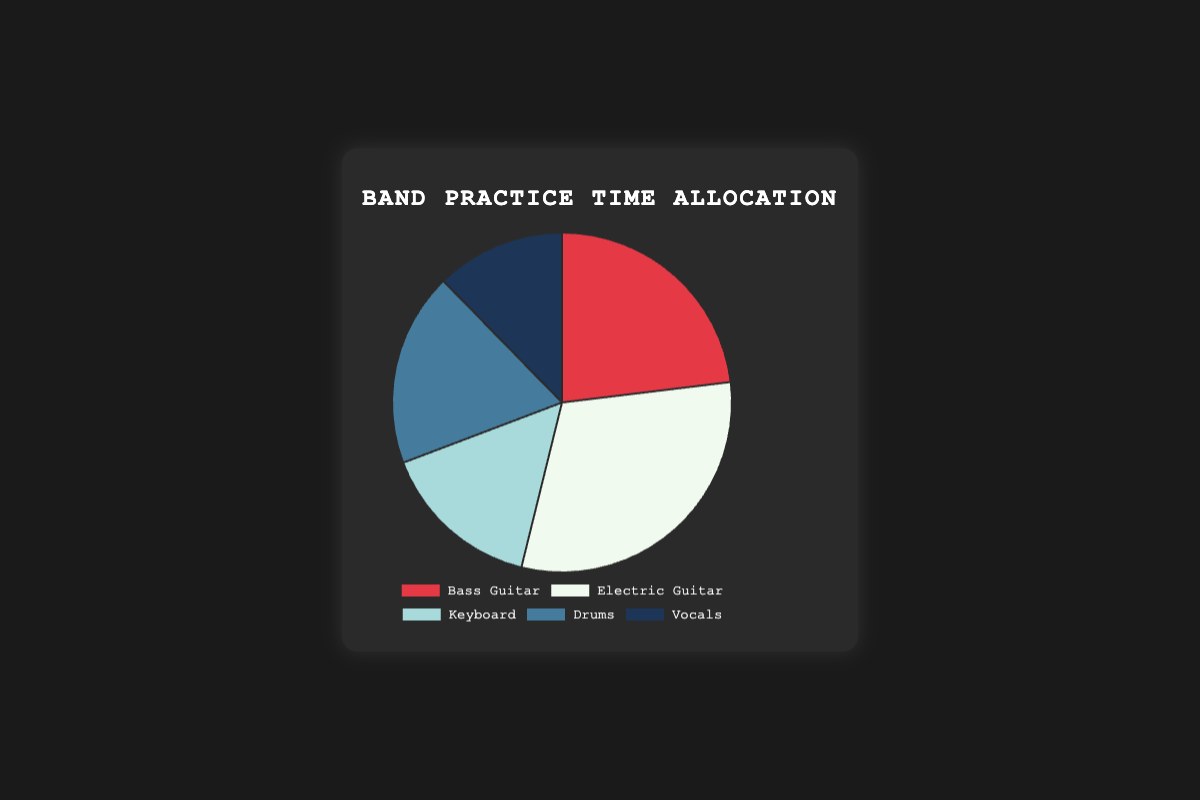Which instrument has the highest practice time allocation per week? The instrument with the highest practice time allocation can be identified by looking at the segment with the largest proportion in the pie chart. The Electric Guitar has the largest segment.
Answer: Electric Guitar Which instrument has the lowest practice time allocation per week? The instrument with the lowest practice time allocation can be identified by looking at the segment with the smallest proportion in the pie chart. The Vocals segment is the smallest.
Answer: Vocals How much more practice time is allocated to the Electric Guitar compared to the Keyboard? To find the difference, subtract the practice time of the Keyboard from the practice time of the Electric Guitar: 20 hours (Electric Guitar) - 10 hours (Keyboard).
Answer: 10 hours What is the total practice time allocated to Bass Guitar and Drums combined per week? To find the total practice time for both instruments, add their practice times: 15 hours (Bass Guitar) + 12 hours (Drums).
Answer: 27 hours What percentage of the total practice time does the Keyboard occupy? Calculate the total practice time for all instruments and then find the percentage for the Keyboard. The total is 15 + 20 + 10 + 12 + 8 = 65 hours. The percentage for the Keyboard is (10/65) * 100.
Answer: 15.38% Which instruments together make up more practice time than Drums alone? First note the practice time of Drums, which is 12 hours. Identify the pairs of other instruments whose combined practice time exceeds 12 hours. Bass Guitar (15), Electric Guitar (20), and combinations such as Bass Guitar + Keyboard (15 + 10) also exceed 12 hours.
Answer: Bass Guitar, Electric Guitar, or Bass Guitar + Keyboard What is the ratio of practice time allocated to Bass Guitar to Drums? The ratio can be found by dividing the practice time of Bass Guitar by the practice time of Drums: 15 hours (Bass Guitar) / 12 hours (Drums).
Answer: 1.25 How much total practice time is allocated to instruments excluding Electric Guitar and Vocals? Sum the practice times excluding Electric Guitar and Vocals: 15 hours (Bass Guitar) + 10 hours (Keyboard) + 12 hours (Drums).
Answer: 37 hours If practice time allocation for Vocals is increased by 50%, what will be the new practice time for Vocals? Calculate 50% of the current practice time for Vocals and add it to the original: 8 hours * 50% = 4 hours. New practice time = 8 hours + 4 hours.
Answer: 12 hours What is the average practice time allocated per instrument per week? Calculate the total practice time and divide by the number of instruments: Total is 15 + 20 + 10 + 12 + 8 = 65 hours. Divide by 5 (number of instruments).
Answer: 13 hours 